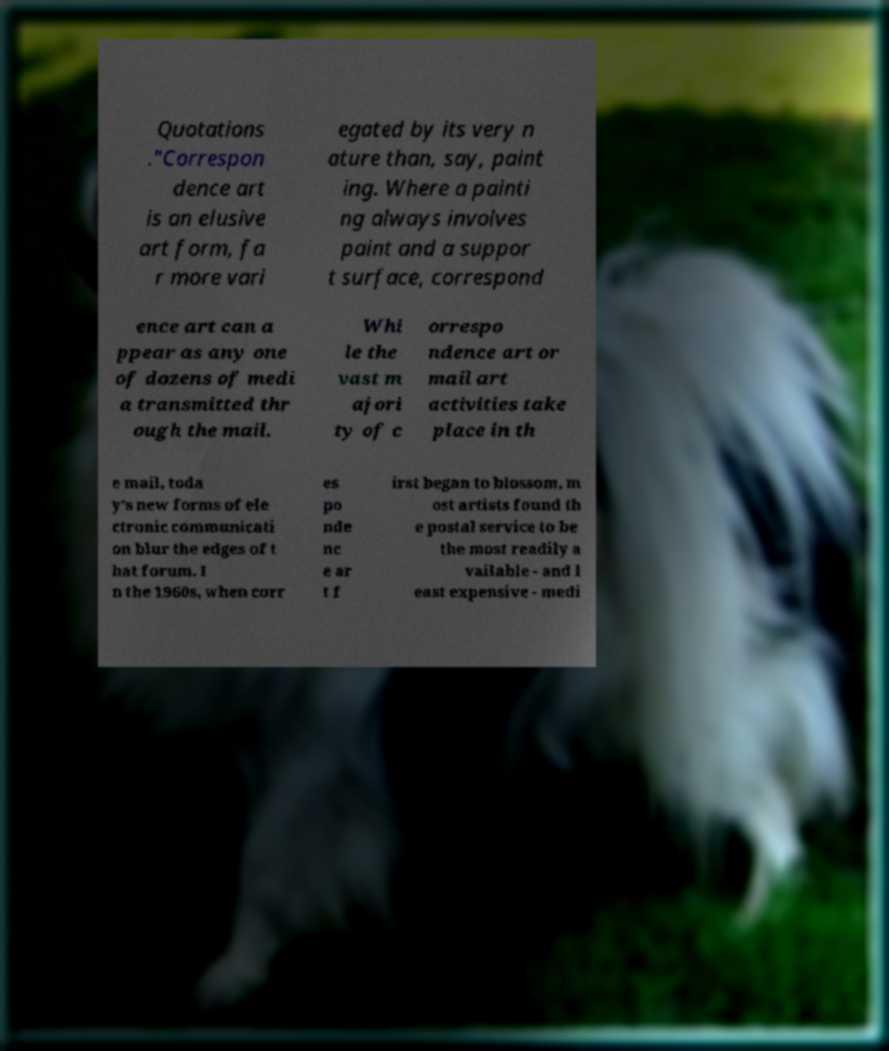Can you read and provide the text displayed in the image?This photo seems to have some interesting text. Can you extract and type it out for me? Quotations ."Correspon dence art is an elusive art form, fa r more vari egated by its very n ature than, say, paint ing. Where a painti ng always involves paint and a suppor t surface, correspond ence art can a ppear as any one of dozens of medi a transmitted thr ough the mail. Whi le the vast m ajori ty of c orrespo ndence art or mail art activities take place in th e mail, toda y's new forms of ele ctronic communicati on blur the edges of t hat forum. I n the 1960s, when corr es po nde nc e ar t f irst began to blossom, m ost artists found th e postal service to be the most readily a vailable - and l east expensive - medi 